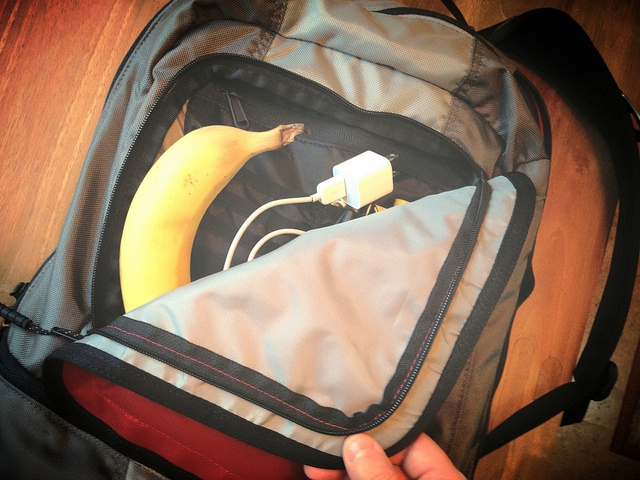Describe the objects in this image and their specific colors. I can see backpack in black, maroon, gray, tan, and beige tones and banana in maroon, khaki, orange, and lightyellow tones in this image. 